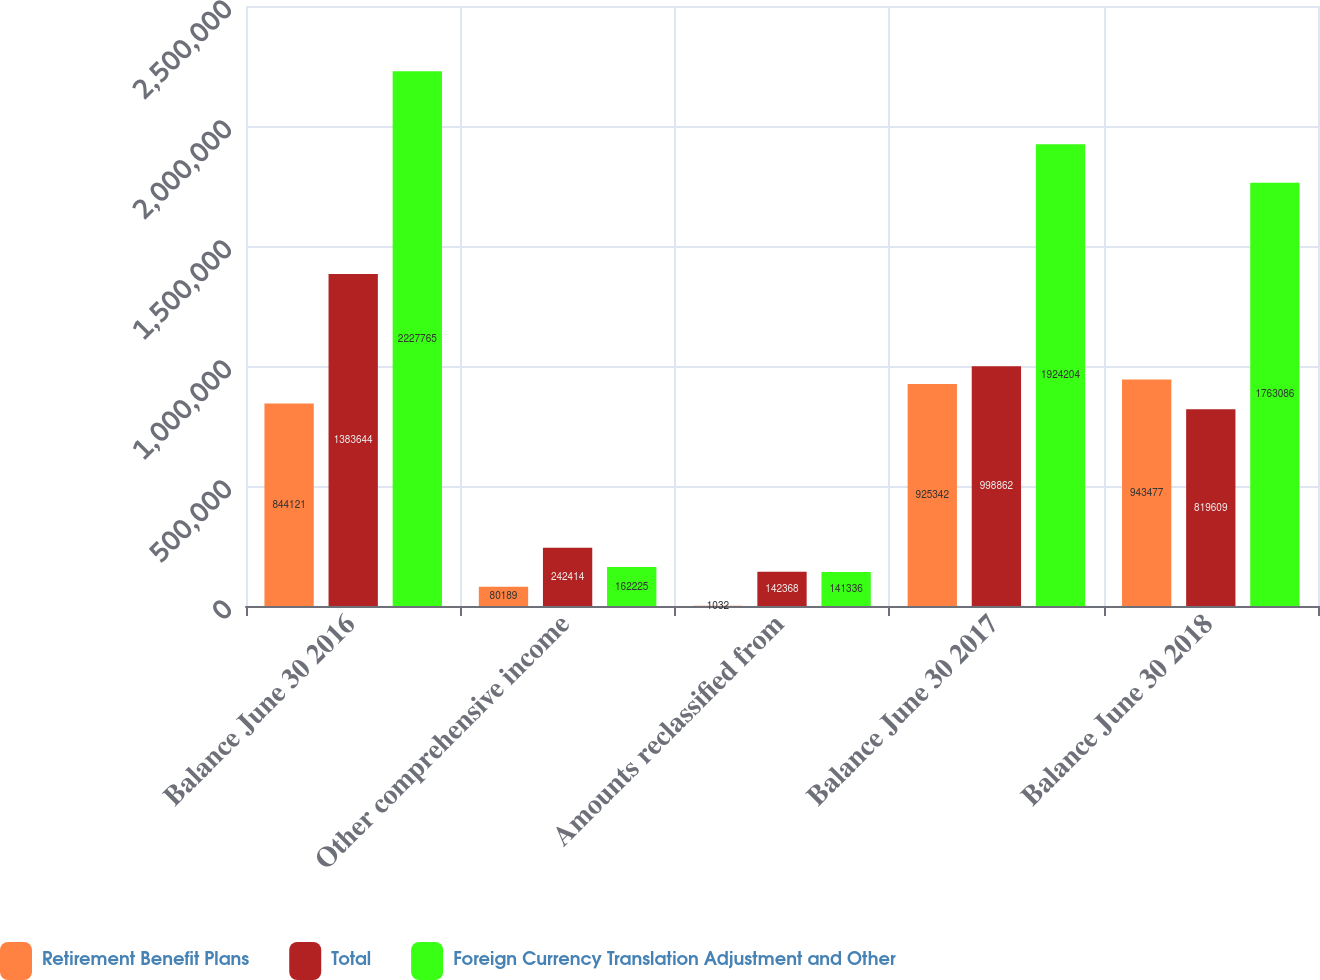Convert chart. <chart><loc_0><loc_0><loc_500><loc_500><stacked_bar_chart><ecel><fcel>Balance June 30 2016<fcel>Other comprehensive income<fcel>Amounts reclassified from<fcel>Balance June 30 2017<fcel>Balance June 30 2018<nl><fcel>Retirement Benefit Plans<fcel>844121<fcel>80189<fcel>1032<fcel>925342<fcel>943477<nl><fcel>Total<fcel>1.38364e+06<fcel>242414<fcel>142368<fcel>998862<fcel>819609<nl><fcel>Foreign Currency Translation Adjustment and Other<fcel>2.22776e+06<fcel>162225<fcel>141336<fcel>1.9242e+06<fcel>1.76309e+06<nl></chart> 